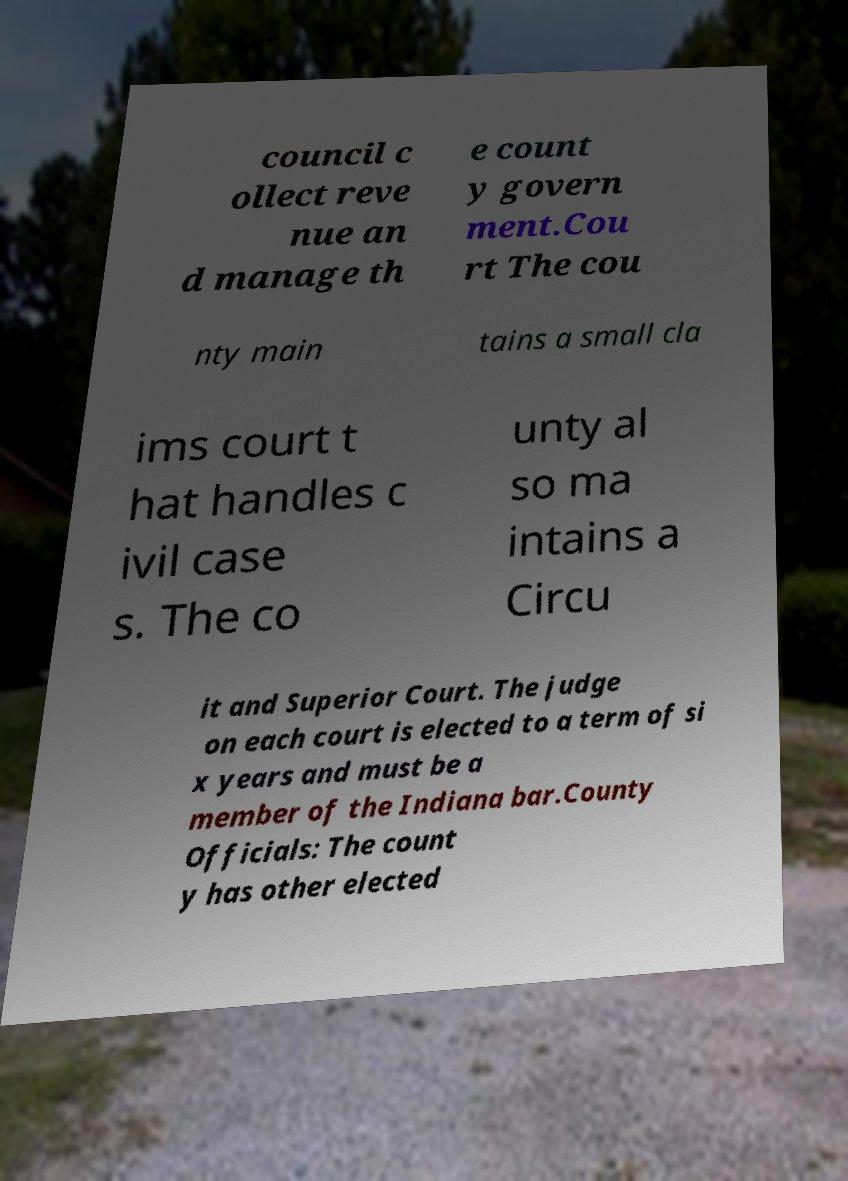What messages or text are displayed in this image? I need them in a readable, typed format. council c ollect reve nue an d manage th e count y govern ment.Cou rt The cou nty main tains a small cla ims court t hat handles c ivil case s. The co unty al so ma intains a Circu it and Superior Court. The judge on each court is elected to a term of si x years and must be a member of the Indiana bar.County Officials: The count y has other elected 